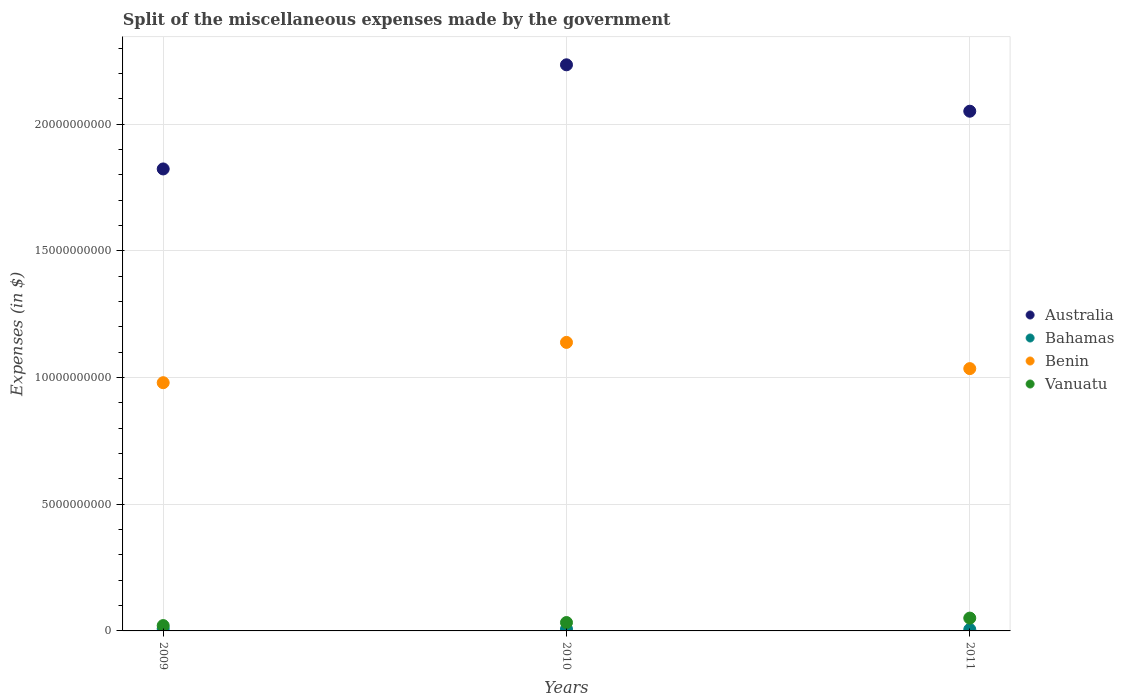What is the miscellaneous expenses made by the government in Benin in 2009?
Your answer should be very brief. 9.79e+09. Across all years, what is the maximum miscellaneous expenses made by the government in Benin?
Offer a very short reply. 1.14e+1. Across all years, what is the minimum miscellaneous expenses made by the government in Benin?
Provide a short and direct response. 9.79e+09. In which year was the miscellaneous expenses made by the government in Vanuatu maximum?
Your answer should be compact. 2011. In which year was the miscellaneous expenses made by the government in Bahamas minimum?
Ensure brevity in your answer.  2011. What is the total miscellaneous expenses made by the government in Vanuatu in the graph?
Offer a terse response. 1.05e+09. What is the difference between the miscellaneous expenses made by the government in Bahamas in 2010 and that in 2011?
Your answer should be compact. 1.80e+07. What is the difference between the miscellaneous expenses made by the government in Australia in 2011 and the miscellaneous expenses made by the government in Bahamas in 2009?
Your response must be concise. 2.04e+1. What is the average miscellaneous expenses made by the government in Bahamas per year?
Your answer should be compact. 7.31e+07. In the year 2010, what is the difference between the miscellaneous expenses made by the government in Bahamas and miscellaneous expenses made by the government in Benin?
Offer a terse response. -1.13e+1. In how many years, is the miscellaneous expenses made by the government in Bahamas greater than 11000000000 $?
Your response must be concise. 0. What is the ratio of the miscellaneous expenses made by the government in Bahamas in 2010 to that in 2011?
Ensure brevity in your answer.  1.31. Is the difference between the miscellaneous expenses made by the government in Bahamas in 2009 and 2010 greater than the difference between the miscellaneous expenses made by the government in Benin in 2009 and 2010?
Your response must be concise. Yes. What is the difference between the highest and the second highest miscellaneous expenses made by the government in Bahamas?
Provide a succinct answer. 1.01e+07. What is the difference between the highest and the lowest miscellaneous expenses made by the government in Australia?
Your response must be concise. 4.11e+09. Is it the case that in every year, the sum of the miscellaneous expenses made by the government in Benin and miscellaneous expenses made by the government in Vanuatu  is greater than the sum of miscellaneous expenses made by the government in Bahamas and miscellaneous expenses made by the government in Australia?
Keep it short and to the point. No. Does the miscellaneous expenses made by the government in Benin monotonically increase over the years?
Provide a succinct answer. No. Is the miscellaneous expenses made by the government in Bahamas strictly greater than the miscellaneous expenses made by the government in Australia over the years?
Provide a short and direct response. No. Is the miscellaneous expenses made by the government in Vanuatu strictly less than the miscellaneous expenses made by the government in Benin over the years?
Ensure brevity in your answer.  Yes. How many years are there in the graph?
Keep it short and to the point. 3. Are the values on the major ticks of Y-axis written in scientific E-notation?
Offer a very short reply. No. Where does the legend appear in the graph?
Your response must be concise. Center right. How many legend labels are there?
Offer a terse response. 4. What is the title of the graph?
Provide a short and direct response. Split of the miscellaneous expenses made by the government. Does "Marshall Islands" appear as one of the legend labels in the graph?
Provide a short and direct response. No. What is the label or title of the X-axis?
Your answer should be very brief. Years. What is the label or title of the Y-axis?
Your response must be concise. Expenses (in $). What is the Expenses (in $) in Australia in 2009?
Your answer should be compact. 1.82e+1. What is the Expenses (in $) of Bahamas in 2009?
Keep it short and to the point. 8.58e+07. What is the Expenses (in $) of Benin in 2009?
Offer a very short reply. 9.79e+09. What is the Expenses (in $) in Vanuatu in 2009?
Offer a very short reply. 2.11e+08. What is the Expenses (in $) of Australia in 2010?
Make the answer very short. 2.23e+1. What is the Expenses (in $) of Bahamas in 2010?
Offer a terse response. 7.57e+07. What is the Expenses (in $) of Benin in 2010?
Make the answer very short. 1.14e+1. What is the Expenses (in $) of Vanuatu in 2010?
Give a very brief answer. 3.31e+08. What is the Expenses (in $) in Australia in 2011?
Make the answer very short. 2.05e+1. What is the Expenses (in $) of Bahamas in 2011?
Provide a succinct answer. 5.77e+07. What is the Expenses (in $) of Benin in 2011?
Offer a very short reply. 1.03e+1. What is the Expenses (in $) in Vanuatu in 2011?
Offer a terse response. 5.06e+08. Across all years, what is the maximum Expenses (in $) of Australia?
Your answer should be compact. 2.23e+1. Across all years, what is the maximum Expenses (in $) of Bahamas?
Give a very brief answer. 8.58e+07. Across all years, what is the maximum Expenses (in $) in Benin?
Keep it short and to the point. 1.14e+1. Across all years, what is the maximum Expenses (in $) of Vanuatu?
Ensure brevity in your answer.  5.06e+08. Across all years, what is the minimum Expenses (in $) in Australia?
Your response must be concise. 1.82e+1. Across all years, what is the minimum Expenses (in $) in Bahamas?
Provide a short and direct response. 5.77e+07. Across all years, what is the minimum Expenses (in $) in Benin?
Make the answer very short. 9.79e+09. Across all years, what is the minimum Expenses (in $) in Vanuatu?
Offer a terse response. 2.11e+08. What is the total Expenses (in $) of Australia in the graph?
Keep it short and to the point. 6.11e+1. What is the total Expenses (in $) of Bahamas in the graph?
Ensure brevity in your answer.  2.19e+08. What is the total Expenses (in $) in Benin in the graph?
Provide a short and direct response. 3.15e+1. What is the total Expenses (in $) in Vanuatu in the graph?
Offer a terse response. 1.05e+09. What is the difference between the Expenses (in $) in Australia in 2009 and that in 2010?
Your answer should be compact. -4.11e+09. What is the difference between the Expenses (in $) of Bahamas in 2009 and that in 2010?
Ensure brevity in your answer.  1.01e+07. What is the difference between the Expenses (in $) in Benin in 2009 and that in 2010?
Your response must be concise. -1.59e+09. What is the difference between the Expenses (in $) of Vanuatu in 2009 and that in 2010?
Ensure brevity in your answer.  -1.20e+08. What is the difference between the Expenses (in $) in Australia in 2009 and that in 2011?
Your response must be concise. -2.28e+09. What is the difference between the Expenses (in $) in Bahamas in 2009 and that in 2011?
Ensure brevity in your answer.  2.81e+07. What is the difference between the Expenses (in $) in Benin in 2009 and that in 2011?
Your response must be concise. -5.56e+08. What is the difference between the Expenses (in $) in Vanuatu in 2009 and that in 2011?
Your answer should be compact. -2.95e+08. What is the difference between the Expenses (in $) in Australia in 2010 and that in 2011?
Give a very brief answer. 1.83e+09. What is the difference between the Expenses (in $) of Bahamas in 2010 and that in 2011?
Offer a very short reply. 1.80e+07. What is the difference between the Expenses (in $) in Benin in 2010 and that in 2011?
Your answer should be compact. 1.03e+09. What is the difference between the Expenses (in $) of Vanuatu in 2010 and that in 2011?
Offer a terse response. -1.75e+08. What is the difference between the Expenses (in $) in Australia in 2009 and the Expenses (in $) in Bahamas in 2010?
Give a very brief answer. 1.82e+1. What is the difference between the Expenses (in $) in Australia in 2009 and the Expenses (in $) in Benin in 2010?
Provide a short and direct response. 6.84e+09. What is the difference between the Expenses (in $) of Australia in 2009 and the Expenses (in $) of Vanuatu in 2010?
Your answer should be compact. 1.79e+1. What is the difference between the Expenses (in $) of Bahamas in 2009 and the Expenses (in $) of Benin in 2010?
Offer a terse response. -1.13e+1. What is the difference between the Expenses (in $) of Bahamas in 2009 and the Expenses (in $) of Vanuatu in 2010?
Make the answer very short. -2.45e+08. What is the difference between the Expenses (in $) of Benin in 2009 and the Expenses (in $) of Vanuatu in 2010?
Offer a terse response. 9.46e+09. What is the difference between the Expenses (in $) in Australia in 2009 and the Expenses (in $) in Bahamas in 2011?
Provide a short and direct response. 1.82e+1. What is the difference between the Expenses (in $) of Australia in 2009 and the Expenses (in $) of Benin in 2011?
Your answer should be very brief. 7.88e+09. What is the difference between the Expenses (in $) in Australia in 2009 and the Expenses (in $) in Vanuatu in 2011?
Your response must be concise. 1.77e+1. What is the difference between the Expenses (in $) of Bahamas in 2009 and the Expenses (in $) of Benin in 2011?
Offer a very short reply. -1.03e+1. What is the difference between the Expenses (in $) in Bahamas in 2009 and the Expenses (in $) in Vanuatu in 2011?
Offer a terse response. -4.20e+08. What is the difference between the Expenses (in $) of Benin in 2009 and the Expenses (in $) of Vanuatu in 2011?
Your answer should be very brief. 9.29e+09. What is the difference between the Expenses (in $) in Australia in 2010 and the Expenses (in $) in Bahamas in 2011?
Make the answer very short. 2.23e+1. What is the difference between the Expenses (in $) in Australia in 2010 and the Expenses (in $) in Benin in 2011?
Your answer should be very brief. 1.20e+1. What is the difference between the Expenses (in $) of Australia in 2010 and the Expenses (in $) of Vanuatu in 2011?
Your response must be concise. 2.18e+1. What is the difference between the Expenses (in $) in Bahamas in 2010 and the Expenses (in $) in Benin in 2011?
Provide a succinct answer. -1.03e+1. What is the difference between the Expenses (in $) of Bahamas in 2010 and the Expenses (in $) of Vanuatu in 2011?
Your answer should be very brief. -4.30e+08. What is the difference between the Expenses (in $) of Benin in 2010 and the Expenses (in $) of Vanuatu in 2011?
Keep it short and to the point. 1.09e+1. What is the average Expenses (in $) of Australia per year?
Provide a short and direct response. 2.04e+1. What is the average Expenses (in $) in Bahamas per year?
Provide a short and direct response. 7.31e+07. What is the average Expenses (in $) in Benin per year?
Provide a succinct answer. 1.05e+1. What is the average Expenses (in $) of Vanuatu per year?
Give a very brief answer. 3.49e+08. In the year 2009, what is the difference between the Expenses (in $) of Australia and Expenses (in $) of Bahamas?
Give a very brief answer. 1.81e+1. In the year 2009, what is the difference between the Expenses (in $) in Australia and Expenses (in $) in Benin?
Provide a short and direct response. 8.43e+09. In the year 2009, what is the difference between the Expenses (in $) of Australia and Expenses (in $) of Vanuatu?
Your answer should be very brief. 1.80e+1. In the year 2009, what is the difference between the Expenses (in $) in Bahamas and Expenses (in $) in Benin?
Your response must be concise. -9.71e+09. In the year 2009, what is the difference between the Expenses (in $) of Bahamas and Expenses (in $) of Vanuatu?
Offer a terse response. -1.25e+08. In the year 2009, what is the difference between the Expenses (in $) in Benin and Expenses (in $) in Vanuatu?
Provide a short and direct response. 9.58e+09. In the year 2010, what is the difference between the Expenses (in $) in Australia and Expenses (in $) in Bahamas?
Your response must be concise. 2.23e+1. In the year 2010, what is the difference between the Expenses (in $) in Australia and Expenses (in $) in Benin?
Offer a very short reply. 1.10e+1. In the year 2010, what is the difference between the Expenses (in $) of Australia and Expenses (in $) of Vanuatu?
Keep it short and to the point. 2.20e+1. In the year 2010, what is the difference between the Expenses (in $) of Bahamas and Expenses (in $) of Benin?
Your response must be concise. -1.13e+1. In the year 2010, what is the difference between the Expenses (in $) of Bahamas and Expenses (in $) of Vanuatu?
Ensure brevity in your answer.  -2.55e+08. In the year 2010, what is the difference between the Expenses (in $) of Benin and Expenses (in $) of Vanuatu?
Provide a short and direct response. 1.11e+1. In the year 2011, what is the difference between the Expenses (in $) in Australia and Expenses (in $) in Bahamas?
Offer a terse response. 2.04e+1. In the year 2011, what is the difference between the Expenses (in $) of Australia and Expenses (in $) of Benin?
Provide a short and direct response. 1.02e+1. In the year 2011, what is the difference between the Expenses (in $) of Australia and Expenses (in $) of Vanuatu?
Make the answer very short. 2.00e+1. In the year 2011, what is the difference between the Expenses (in $) of Bahamas and Expenses (in $) of Benin?
Offer a terse response. -1.03e+1. In the year 2011, what is the difference between the Expenses (in $) of Bahamas and Expenses (in $) of Vanuatu?
Your answer should be very brief. -4.48e+08. In the year 2011, what is the difference between the Expenses (in $) in Benin and Expenses (in $) in Vanuatu?
Keep it short and to the point. 9.84e+09. What is the ratio of the Expenses (in $) in Australia in 2009 to that in 2010?
Offer a terse response. 0.82. What is the ratio of the Expenses (in $) in Bahamas in 2009 to that in 2010?
Make the answer very short. 1.13. What is the ratio of the Expenses (in $) of Benin in 2009 to that in 2010?
Give a very brief answer. 0.86. What is the ratio of the Expenses (in $) in Vanuatu in 2009 to that in 2010?
Give a very brief answer. 0.64. What is the ratio of the Expenses (in $) in Australia in 2009 to that in 2011?
Make the answer very short. 0.89. What is the ratio of the Expenses (in $) of Bahamas in 2009 to that in 2011?
Provide a short and direct response. 1.49. What is the ratio of the Expenses (in $) of Benin in 2009 to that in 2011?
Your answer should be very brief. 0.95. What is the ratio of the Expenses (in $) in Vanuatu in 2009 to that in 2011?
Your answer should be compact. 0.42. What is the ratio of the Expenses (in $) in Australia in 2010 to that in 2011?
Your answer should be very brief. 1.09. What is the ratio of the Expenses (in $) of Bahamas in 2010 to that in 2011?
Your answer should be compact. 1.31. What is the ratio of the Expenses (in $) of Benin in 2010 to that in 2011?
Your answer should be compact. 1.1. What is the ratio of the Expenses (in $) in Vanuatu in 2010 to that in 2011?
Your answer should be compact. 0.65. What is the difference between the highest and the second highest Expenses (in $) in Australia?
Offer a terse response. 1.83e+09. What is the difference between the highest and the second highest Expenses (in $) of Bahamas?
Your answer should be compact. 1.01e+07. What is the difference between the highest and the second highest Expenses (in $) of Benin?
Your answer should be compact. 1.03e+09. What is the difference between the highest and the second highest Expenses (in $) of Vanuatu?
Your answer should be compact. 1.75e+08. What is the difference between the highest and the lowest Expenses (in $) of Australia?
Offer a terse response. 4.11e+09. What is the difference between the highest and the lowest Expenses (in $) of Bahamas?
Give a very brief answer. 2.81e+07. What is the difference between the highest and the lowest Expenses (in $) in Benin?
Ensure brevity in your answer.  1.59e+09. What is the difference between the highest and the lowest Expenses (in $) in Vanuatu?
Make the answer very short. 2.95e+08. 